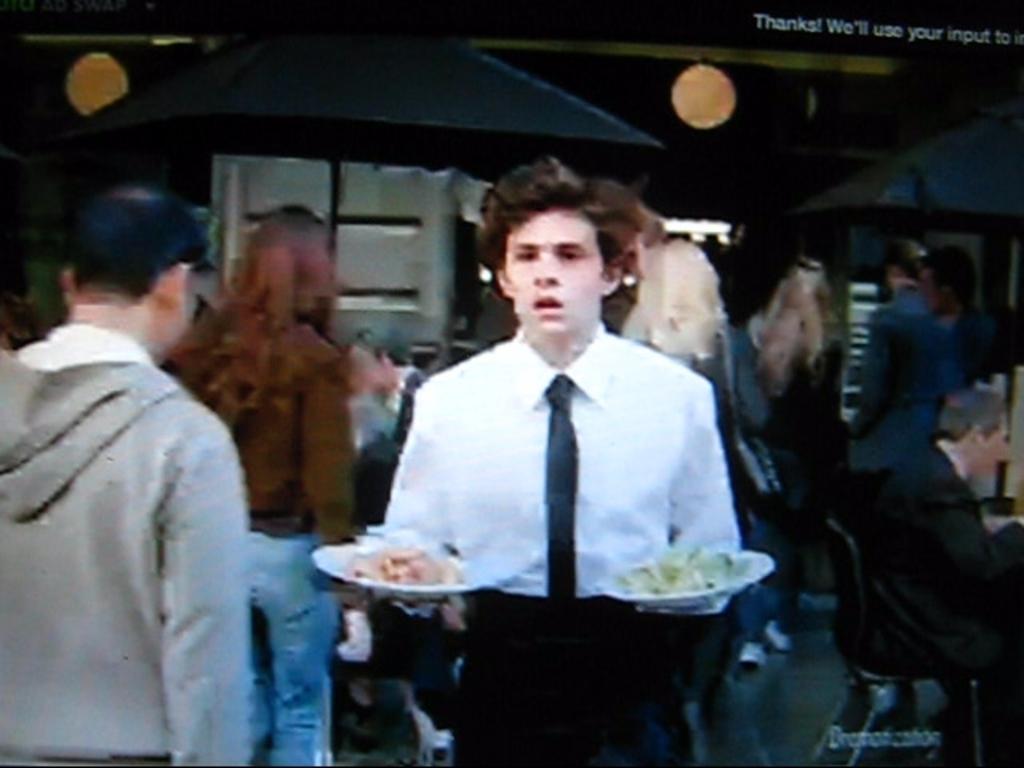Could you give a brief overview of what you see in this image? In the center of the image we can see a person standing and he is holding some objects. On the left side of the image, we can see one person is standing. In the background, there is a wall, one person is sitting, few people are standing and a few other objects. 